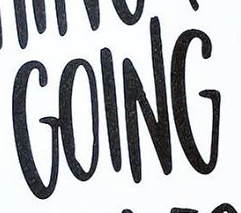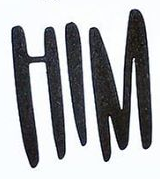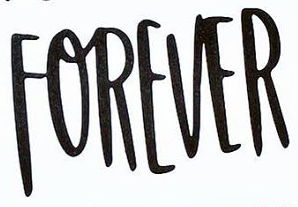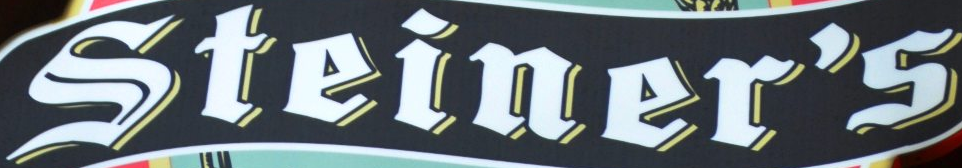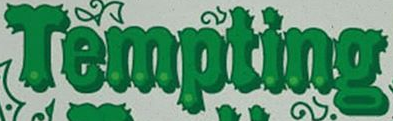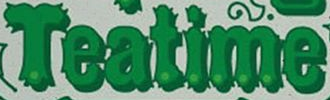Transcribe the words shown in these images in order, separated by a semicolon. GOING; HIM; FOREVER; Steiner's; Tempting; Teatime 